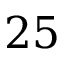Convert formula to latex. <formula><loc_0><loc_0><loc_500><loc_500>2 5</formula> 